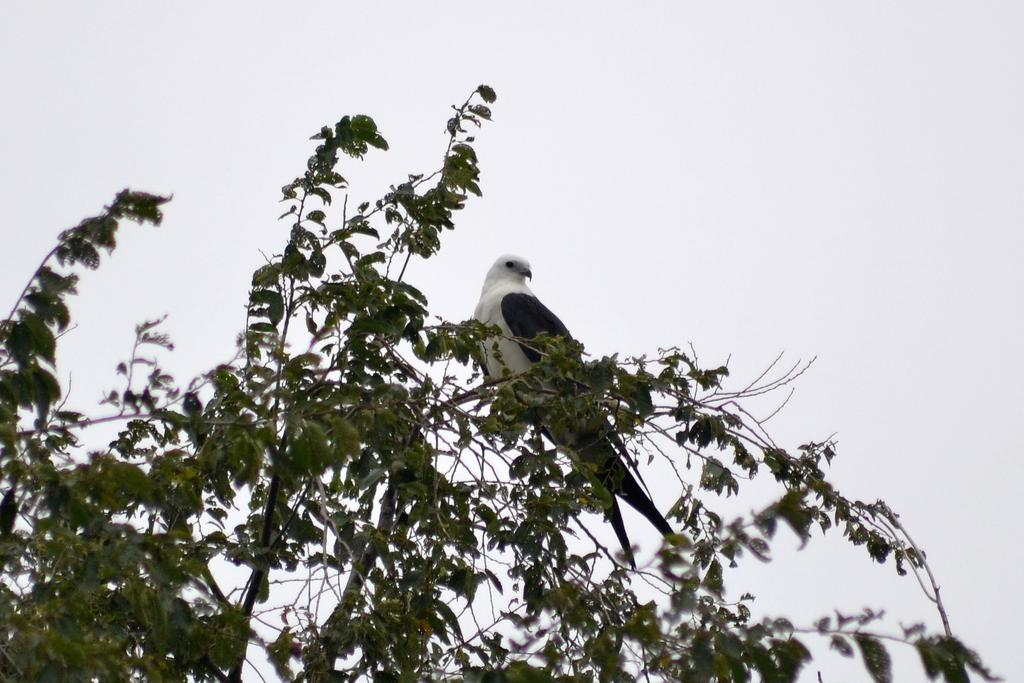What type of animal can be seen in the image? There is a bird in the image. Where is the bird located? The bird is on a tree. What can be seen in the background of the image? There is sky visible in the background of the image. How many pizzas are being delivered by the bird in the image? There are no pizzas present in the image, and the bird is not delivering anything. 